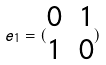<formula> <loc_0><loc_0><loc_500><loc_500>e _ { 1 } = ( \begin{matrix} 0 & 1 \\ 1 & 0 \end{matrix} )</formula> 